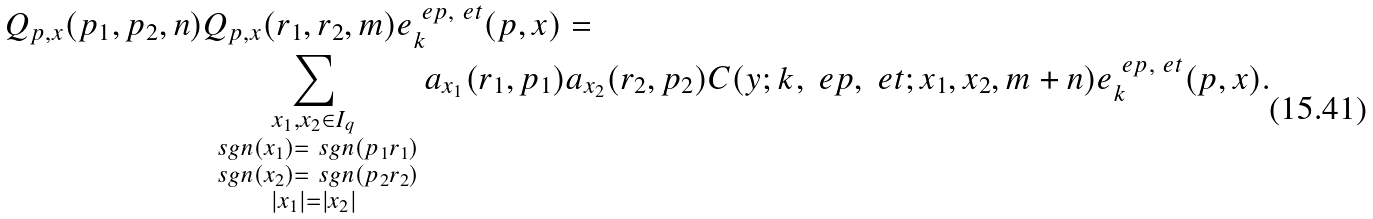Convert formula to latex. <formula><loc_0><loc_0><loc_500><loc_500>Q _ { p , x } ( p _ { 1 } , p _ { 2 } , n ) & Q _ { p , x } ( r _ { 1 } , r _ { 2 } , m ) e _ { k } ^ { \ e p , \ e t } ( p , x ) = \\ & \sum _ { \substack { x _ { 1 } , x _ { 2 } \in I _ { q } \\ \ s g n ( x _ { 1 } ) = \ s g n ( p _ { 1 } r _ { 1 } ) \\ \ s g n ( x _ { 2 } ) = \ s g n ( p _ { 2 } r _ { 2 } ) \\ | x _ { 1 } | = | x _ { 2 } | } } a _ { x _ { 1 } } ( r _ { 1 } , p _ { 1 } ) a _ { x _ { 2 } } ( r _ { 2 } , p _ { 2 } ) C ( y ; k , \ e p , \ e t ; x _ { 1 } , x _ { 2 } , m + n ) e _ { k } ^ { \ e p , \ e t } ( p , x ) .</formula> 